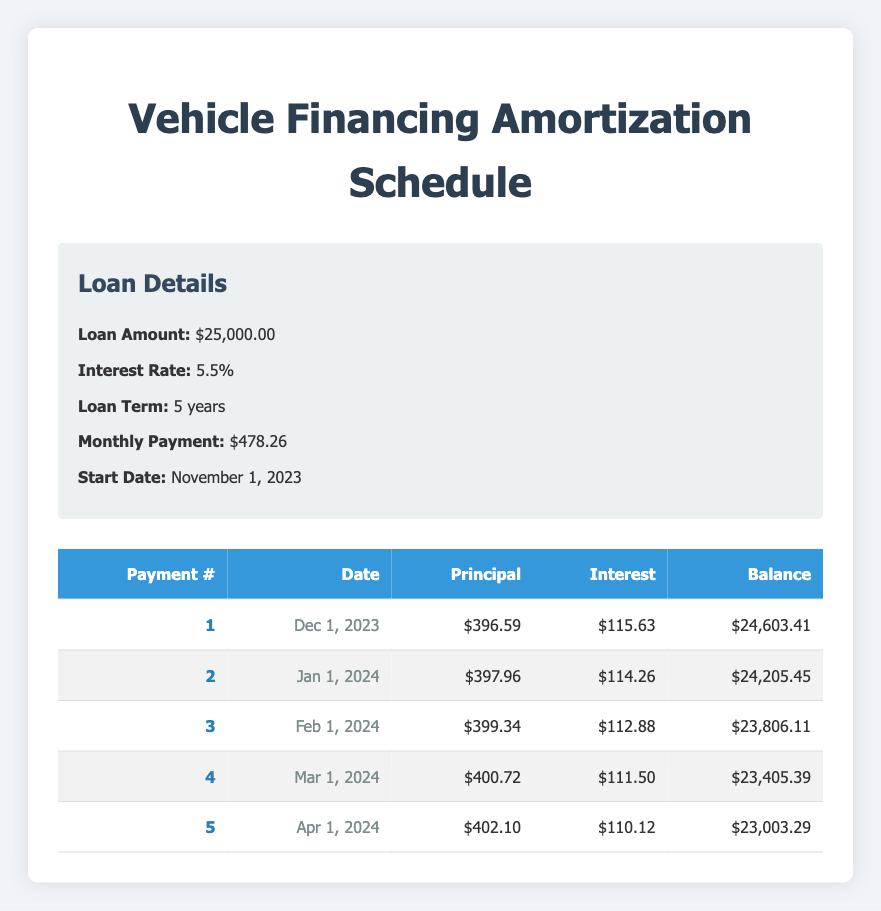What is the total amount of principal paid in the first 5 payments? To find the total principal paid, we sum the principal payments for each of the first five payments: 396.59 + 397.96 + 399.34 + 400.72 + 402.10 = 1996.71.
Answer: 1996.71 What is the interest payment on the second payment? The interest payment on the second payment is specifically listed in the table as 114.26.
Answer: 114.26 Is the remaining balance after the first payment greater than 24,500? The remaining balance after the first payment is 24,603.41, which is greater than 24,500. Therefore, the answer is yes.
Answer: Yes What is the difference in principal payments between the first and fifth payments? The principal payment for the first payment is 396.59 and for the fifth payment it is 402.10. The difference is calculated as 402.10 - 396.59 = 5.51.
Answer: 5.51 What is the average interest payment over the first 5 payments? The average interest payment is calculated by summing the interest payments: 115.63 + 114.26 + 112.88 + 111.50 + 110.12 = 564.39 and then dividing by the number of payments (5), which gives 564.39 / 5 = 112.878.
Answer: 112.88 What is the remaining balance after the third payment? The remaining balance after the third payment is explicitly stated in the table as 23,806.11.
Answer: 23,806.11 Was the principal payment in the fourth month greater than the interest payment? The principal payment in the fourth month is 400.72 and the interest payment is 111.50. Since 400.72 is greater than 111.50, the answer is yes.
Answer: Yes How much total payment will be made towards the interest in the first half of the loan term (first 30 months)? The data provided only includes the first 5 payments, so we can only calculate the interest for those. The total interest paid in the first 5 payments is 115.63 + 114.26 + 112.88 + 111.50 + 110.12 = 564.39. Since we cannot predict future values accurately from the current data, we would just state what can be calculated.
Answer: 564.39 What is the date of the last payment in the first 5 payments? The date for the fifth payment is April 1, 2024, which is the last payment in the provided data.
Answer: April 1, 2024 